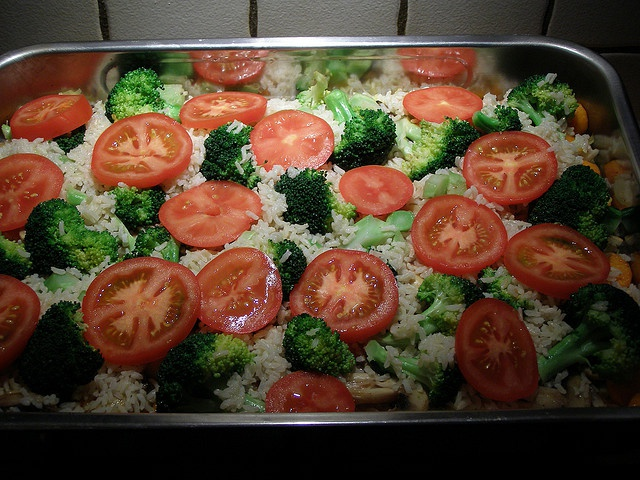Describe the objects in this image and their specific colors. I can see broccoli in black, darkgreen, and gray tones, broccoli in black and darkgreen tones, broccoli in black, darkgreen, and gray tones, broccoli in black, darkgreen, maroon, and olive tones, and broccoli in black, darkgreen, and maroon tones in this image. 